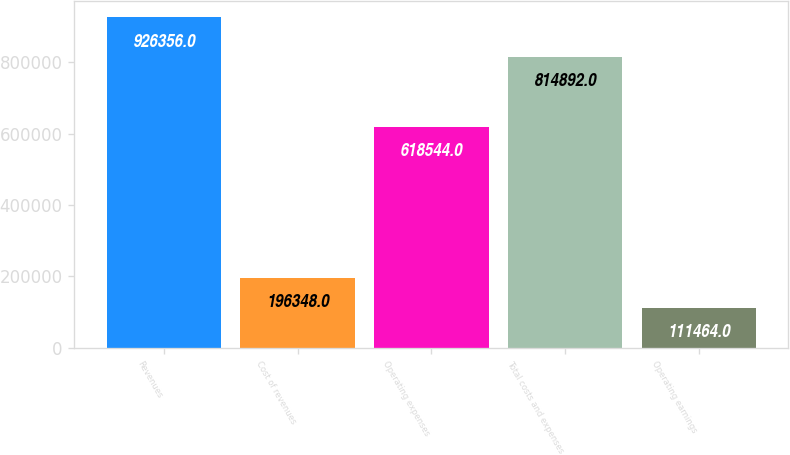Convert chart to OTSL. <chart><loc_0><loc_0><loc_500><loc_500><bar_chart><fcel>Revenues<fcel>Cost of revenues<fcel>Operating expenses<fcel>Total costs and expenses<fcel>Operating earnings<nl><fcel>926356<fcel>196348<fcel>618544<fcel>814892<fcel>111464<nl></chart> 